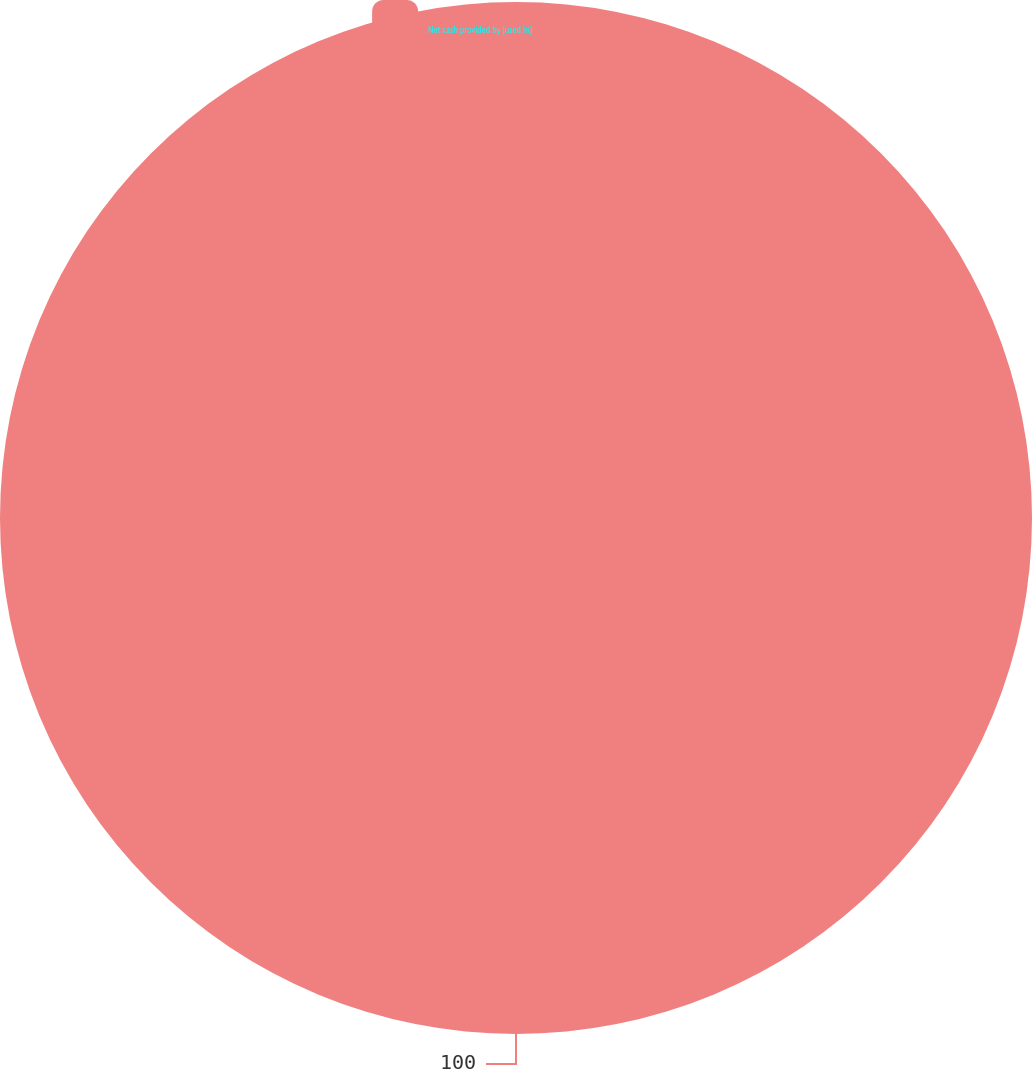<chart> <loc_0><loc_0><loc_500><loc_500><pie_chart><fcel>Net cash provided by (used in)<nl><fcel>100.0%<nl></chart> 